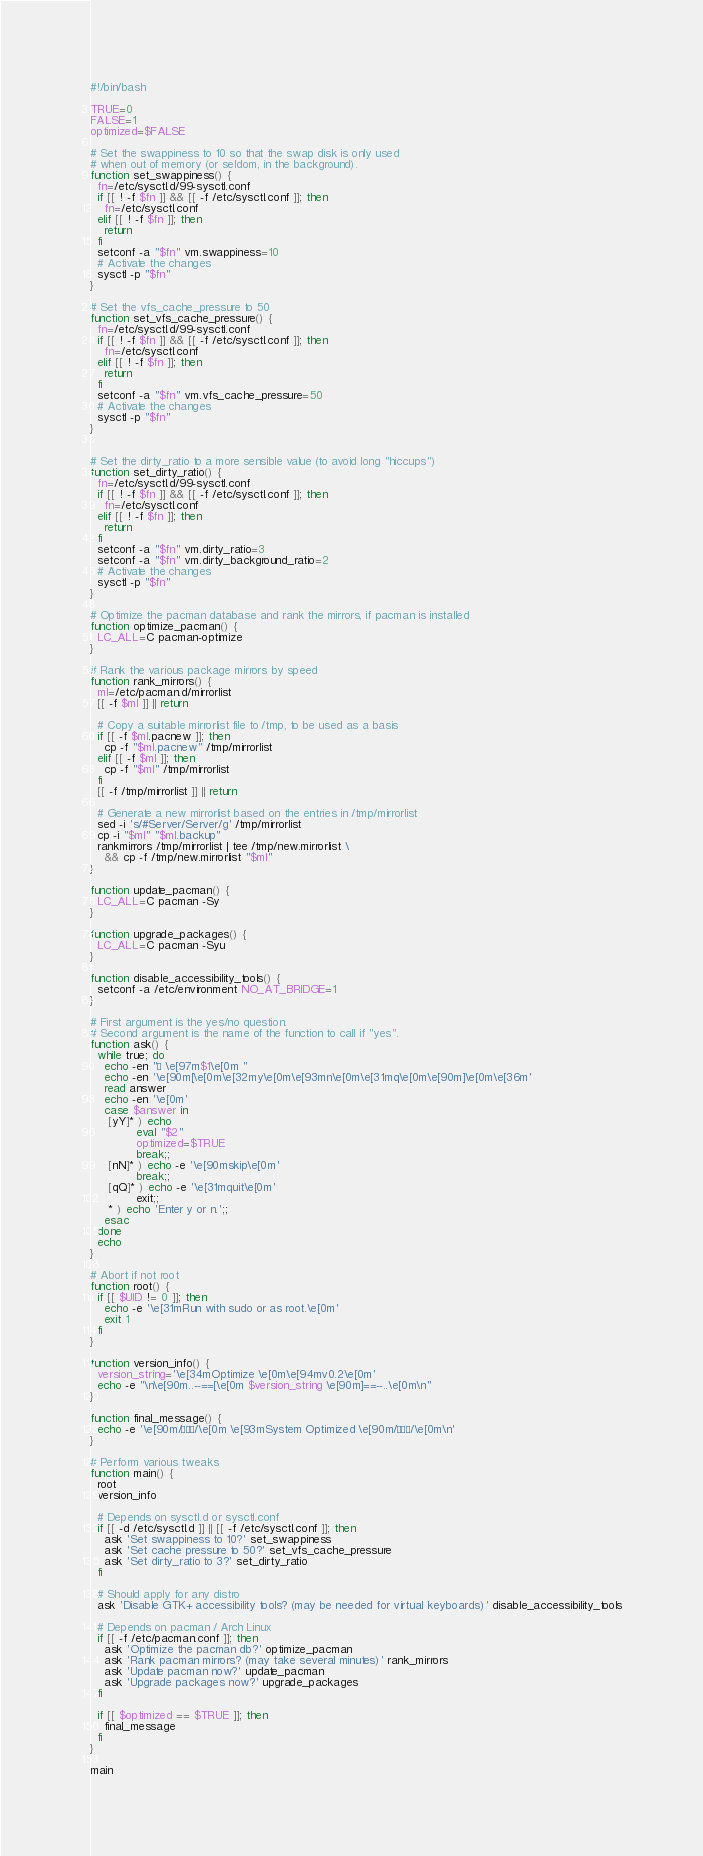Convert code to text. <code><loc_0><loc_0><loc_500><loc_500><_Bash_>#!/bin/bash

TRUE=0
FALSE=1
optimized=$FALSE

# Set the swappiness to 10 so that the swap disk is only used
# when out of memory (or seldom, in the background).
function set_swappiness() {
  fn=/etc/sysctl.d/99-sysctl.conf
  if [[ ! -f $fn ]] && [[ -f /etc/sysctl.conf ]]; then
    fn=/etc/sysctl.conf
  elif [[ ! -f $fn ]]; then
    return
  fi
  setconf -a "$fn" vm.swappiness=10
  # Activate the changes
  sysctl -p "$fn"
}

# Set the vfs_cache_pressure to 50
function set_vfs_cache_pressure() {
  fn=/etc/sysctl.d/99-sysctl.conf
  if [[ ! -f $fn ]] && [[ -f /etc/sysctl.conf ]]; then
    fn=/etc/sysctl.conf
  elif [[ ! -f $fn ]]; then
    return
  fi
  setconf -a "$fn" vm.vfs_cache_pressure=50
  # Activate the changes
  sysctl -p "$fn"
}


# Set the dirty_ratio to a more sensible value (to avoid long "hiccups")
function set_dirty_ratio() {
  fn=/etc/sysctl.d/99-sysctl.conf
  if [[ ! -f $fn ]] && [[ -f /etc/sysctl.conf ]]; then
    fn=/etc/sysctl.conf
  elif [[ ! -f $fn ]]; then
    return
  fi
  setconf -a "$fn" vm.dirty_ratio=3
  setconf -a "$fn" vm.dirty_background_ratio=2
  # Activate the changes
  sysctl -p "$fn"
}

# Optimize the pacman database and rank the mirrors, if pacman is installed
function optimize_pacman() {
  LC_ALL=C pacman-optimize
}

# Rank the various package mirrors by speed
function rank_mirrors() {
  ml=/etc/pacman.d/mirrorlist
  [[ -f $ml ]] || return

  # Copy a suitable mirrorlist file to /tmp, to be used as a basis
  if [[ -f $ml.pacnew ]]; then
    cp -f "$ml.pacnew" /tmp/mirrorlist
  elif [[ -f $ml ]]; then
    cp -f "$ml" /tmp/mirrorlist
  fi
  [[ -f /tmp/mirrorlist ]] || return

  # Generate a new mirrorlist based on the entries in /tmp/mirrorlist
  sed -i 's/#Server/Server/g' /tmp/mirrorlist
  cp -i "$ml" "$ml.backup"
  rankmirrors /tmp/mirrorlist | tee /tmp/new.mirrorlist \
    && cp -f /tmp/new.mirrorlist "$ml"
}

function update_pacman() {
  LC_ALL=C pacman -Sy
}

function upgrade_packages() {
  LC_ALL=C pacman -Syu
}

function disable_accessibility_tools() {
  setconf -a /etc/environment NO_AT_BRIDGE=1
}

# First argument is the yes/no question.
# Second argument is the name of the function to call if "yes".
function ask() {
  while true; do
    echo -en "· \e[97m$1\e[0m "
    echo -en '\e[90m[\e[0m\e[32my\e[0m\e[93mn\e[0m\e[31mq\e[0m\e[90m]\e[0m\e[36m'
    read answer
    echo -en '\e[0m'
    case $answer in
     [yY]* ) echo
             eval "$2"
             optimized=$TRUE
             break;;
     [nN]* ) echo -e '\e[90mskip\e[0m'
             break;;
     [qQ]* ) echo -e '\e[31mquit\e[0m'
             exit;;
     * ) echo 'Enter y or n.';;
    esac
  done
  echo
}

# Abort if not root
function root() {
  if [[ $UID != 0 ]]; then
    echo -e '\e[31mRun with sudo or as root.\e[0m'
    exit 1
  fi
}

function version_info() {
  version_string='\e[34mOptimize \e[0m\e[94mv0.2\e[0m'
  echo -e "\n\e[90m..--==[\e[0m $version_string \e[90m]==--..\e[0m\n"
}

function final_message() {
  echo -e '\e[90m/···/\e[0m \e[93mSystem Optimized \e[90m/···/\e[0m\n'
}

# Perform various tweaks
function main() {
  root
  version_info

  # Depends on sysctl.d or sysctl.conf
  if [[ -d /etc/sysctl.d ]] || [[ -f /etc/sysctl.conf ]]; then
    ask 'Set swappiness to 10?' set_swappiness
    ask 'Set cache pressure to 50?' set_vfs_cache_pressure
    ask 'Set dirty_ratio to 3?' set_dirty_ratio
  fi

  # Should apply for any distro
  ask 'Disable GTK+ accessibility tools? (may be needed for virtual keyboards)' disable_accessibility_tools

  # Depends on pacman / Arch Linux
  if [[ -f /etc/pacman.conf ]]; then
    ask 'Optimize the pacman db?' optimize_pacman
    ask 'Rank pacman mirrors? (may take several minutes)' rank_mirrors
    ask 'Update pacman now?' update_pacman
    ask 'Upgrade packages now?' upgrade_packages
  fi

  if [[ $optimized == $TRUE ]]; then
    final_message
  fi
}

main
</code> 